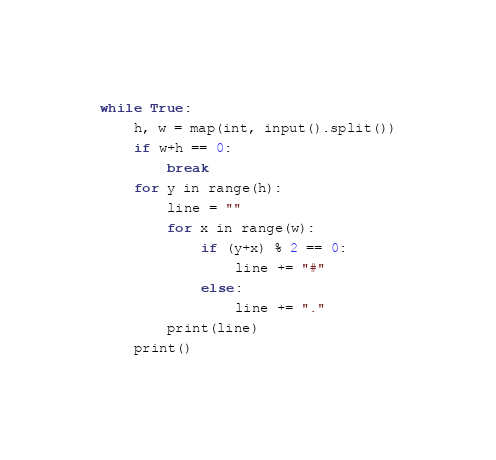Convert code to text. <code><loc_0><loc_0><loc_500><loc_500><_Python_>while True:
    h, w = map(int, input().split())
    if w+h == 0:
        break
    for y in range(h):
        line = ""
        for x in range(w):
            if (y+x) % 2 == 0:
                line += "#"
            else:
                line += "."
        print(line)
    print()

</code> 